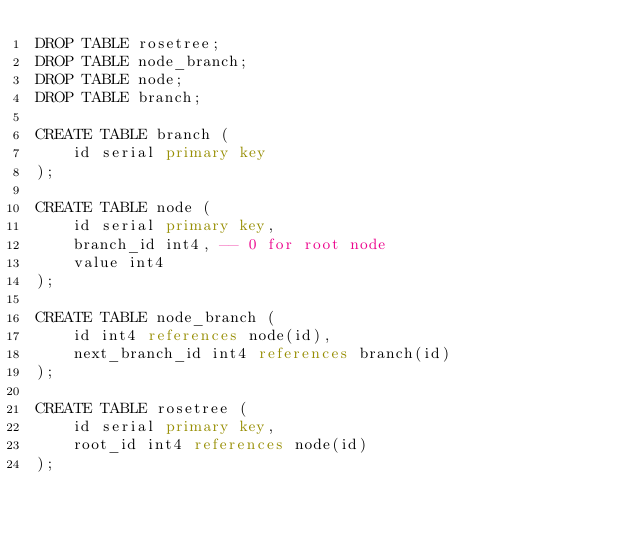<code> <loc_0><loc_0><loc_500><loc_500><_SQL_>DROP TABLE rosetree;
DROP TABLE node_branch;
DROP TABLE node;
DROP TABLE branch;

CREATE TABLE branch (
    id serial primary key
);

CREATE TABLE node (
    id serial primary key,
    branch_id int4, -- 0 for root node
    value int4
);

CREATE TABLE node_branch (
    id int4 references node(id),
    next_branch_id int4 references branch(id)
);

CREATE TABLE rosetree (
    id serial primary key,
    root_id int4 references node(id)
);


</code> 